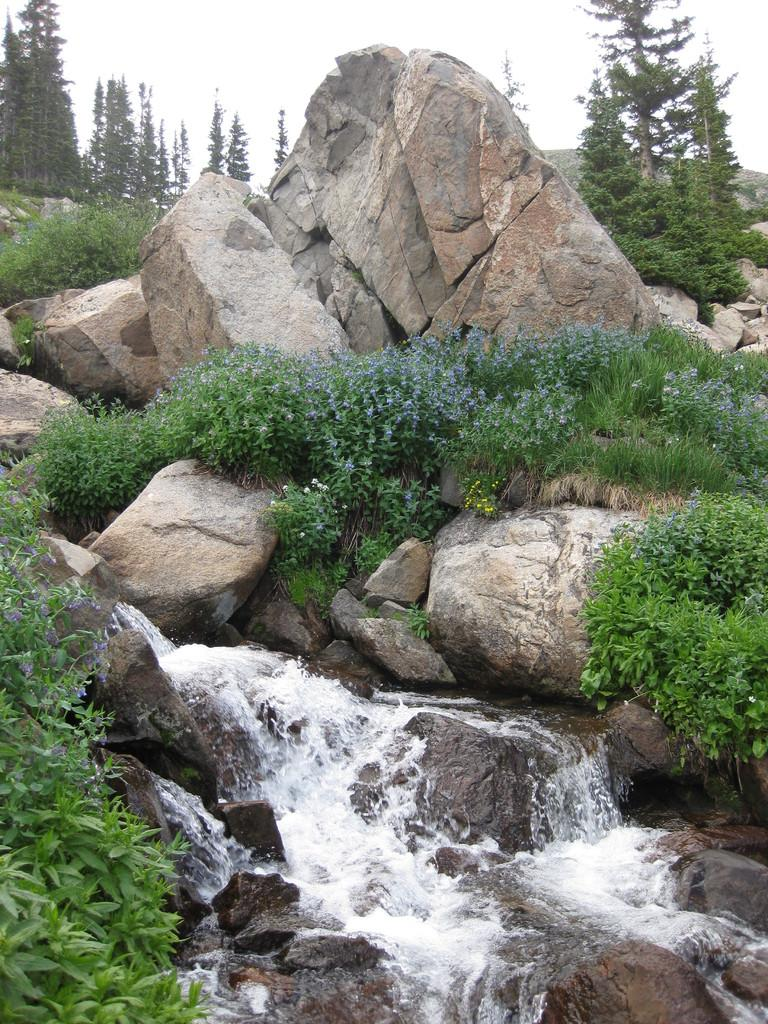What type of natural elements can be seen in the image? There are rocks, water, flowers, plants, and trees visible in the image. Can you describe the sky in the image? The sky is visible in the background of the image. What type of vegetation is present in the image? There are flowers, plants, and trees in the image. What type of spark can be seen coming from the committee in the image? There is no committee or spark present in the image. How many snails are visible on the rocks in the image? There are no snails visible on the rocks in the image. 